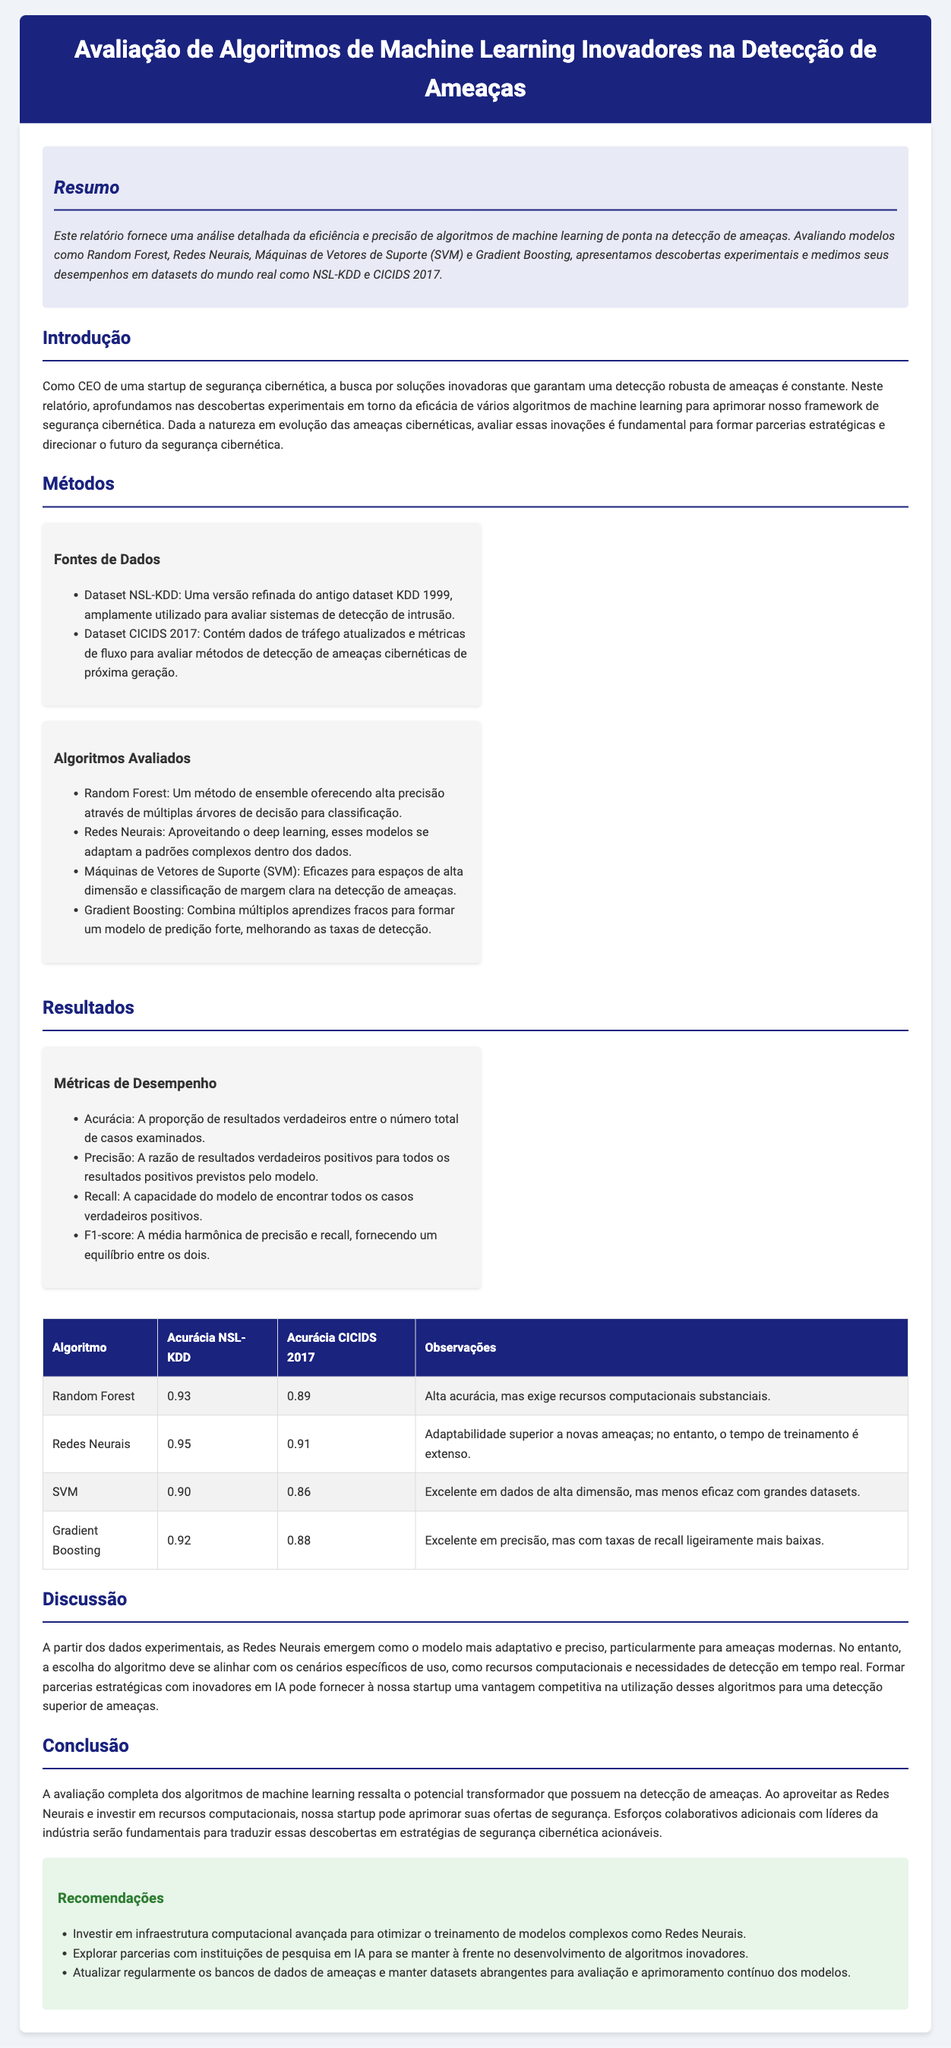qual é o algoritmo com maior acurácia no dataset NSL-KDD? O algoritmo que obteve a maior acurácia no dataset NSL-KDD é Redes Neurais com uma acurácia de 0.95.
Answer: Redes Neurais qual é a precisão do algoritmo SVM no dataset CICIDS 2017? O algoritmo SVM apresentou uma precisão de 0.86 no dataset CICIDS 2017.
Answer: 0.86 quais datasets foram utilizados na avaliação? Os datasets utilizados na avaliação foram NSL-KDD e CICIDS 2017.
Answer: NSL-KDD e CICIDS 2017 qual é um dos principais desafios de utilizar Redes Neurais mencionados no relatório? Um dos principais desafios ao utilizar Redes Neurais é o extenso tempo de treinamento.
Answer: Extenso tempo de treinamento qual algoritmo combinou múltiplos aprendizes fracos para predição forte? O algoritmo que combina múltiplos aprendizes fracos é o Gradient Boosting.
Answer: Gradient Boosting qual métrica é a média harmônica de precisão e recall? A métrica que representa a média harmônica de precisão e recall é o F1-score.
Answer: F1-score o que se recomenda investir para otimizar o treinamento de modelos complexos? A recomendação é investir em infraestrutura computacional avançada.
Answer: Infraestrutura computacional avançada qual é a precisão do algoritmo Random Forest no dataset CICIDS 2017? A precisão do algoritmo Random Forest no dataset CICIDS 2017 é de 0.89.
Answer: 0.89 qual é uma das observações sobre o algoritmo Gradient Boosting? Uma das observações sobre o algoritmo Gradient Boosting é que ele possui taxas de recall ligeiramente mais baixas.
Answer: Taxas de recall ligeiramente mais baixas 